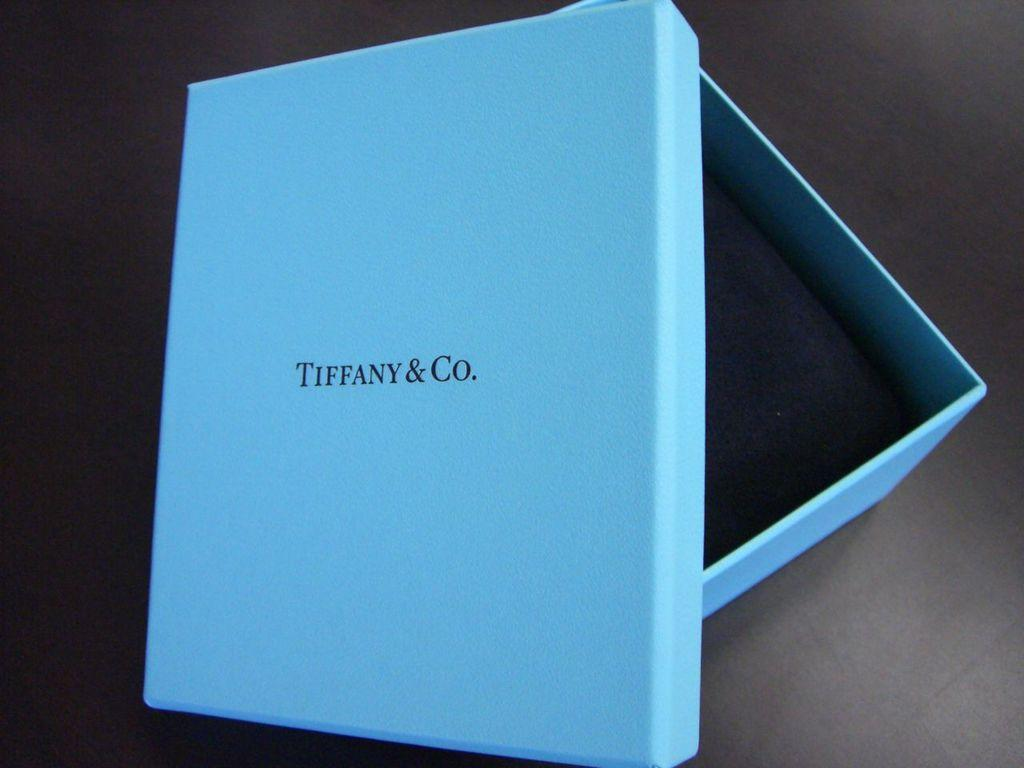<image>
Summarize the visual content of the image. A light blue presentation box for some item Tiffany & Co. 